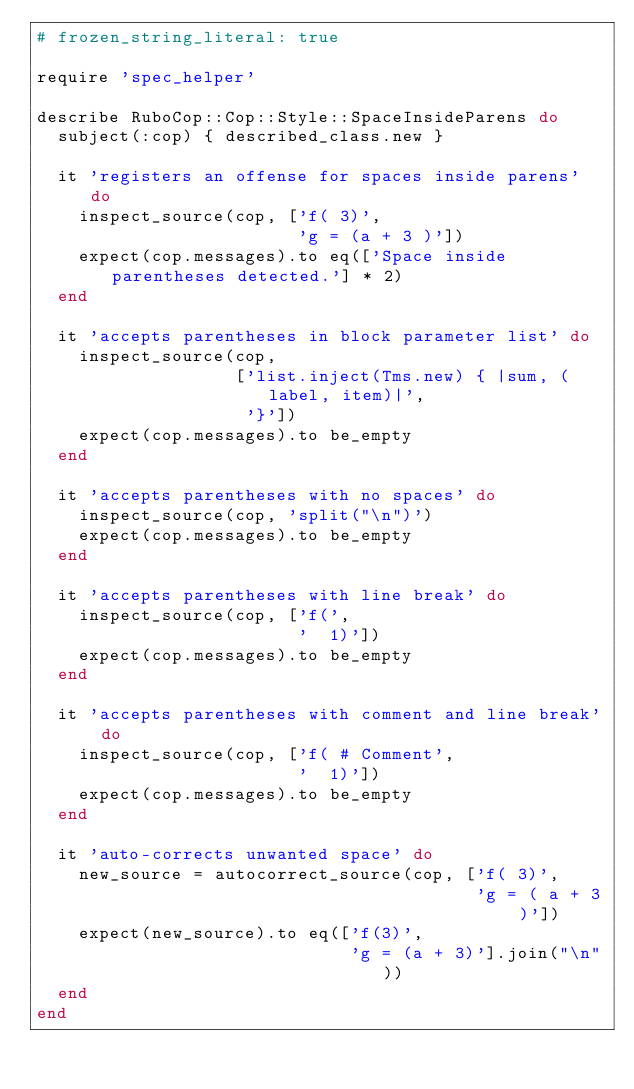<code> <loc_0><loc_0><loc_500><loc_500><_Ruby_># frozen_string_literal: true

require 'spec_helper'

describe RuboCop::Cop::Style::SpaceInsideParens do
  subject(:cop) { described_class.new }

  it 'registers an offense for spaces inside parens' do
    inspect_source(cop, ['f( 3)',
                         'g = (a + 3 )'])
    expect(cop.messages).to eq(['Space inside parentheses detected.'] * 2)
  end

  it 'accepts parentheses in block parameter list' do
    inspect_source(cop,
                   ['list.inject(Tms.new) { |sum, (label, item)|',
                    '}'])
    expect(cop.messages).to be_empty
  end

  it 'accepts parentheses with no spaces' do
    inspect_source(cop, 'split("\n")')
    expect(cop.messages).to be_empty
  end

  it 'accepts parentheses with line break' do
    inspect_source(cop, ['f(',
                         '  1)'])
    expect(cop.messages).to be_empty
  end

  it 'accepts parentheses with comment and line break' do
    inspect_source(cop, ['f( # Comment',
                         '  1)'])
    expect(cop.messages).to be_empty
  end

  it 'auto-corrects unwanted space' do
    new_source = autocorrect_source(cop, ['f( 3)',
                                          'g = ( a + 3 )'])
    expect(new_source).to eq(['f(3)',
                              'g = (a + 3)'].join("\n"))
  end
end
</code> 